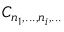<formula> <loc_0><loc_0><loc_500><loc_500>C _ { n _ { 1 } , \dots , n _ { i } , \dots }</formula> 